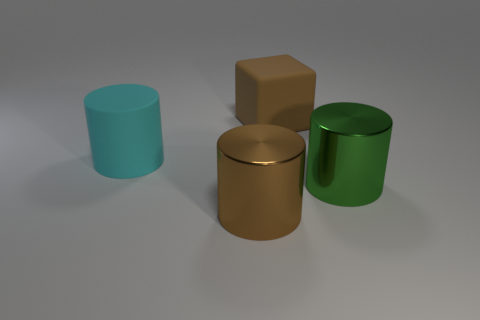Subtract all big metal cylinders. How many cylinders are left? 1 Add 4 cyan matte objects. How many objects exist? 8 Subtract all cyan cylinders. How many cylinders are left? 2 Subtract all cubes. How many objects are left? 3 Subtract 1 cylinders. How many cylinders are left? 2 Subtract all brown objects. Subtract all small cyan rubber things. How many objects are left? 2 Add 2 large metallic cylinders. How many large metallic cylinders are left? 4 Add 3 big yellow shiny cubes. How many big yellow shiny cubes exist? 3 Subtract 0 red cylinders. How many objects are left? 4 Subtract all yellow cubes. Subtract all red cylinders. How many cubes are left? 1 